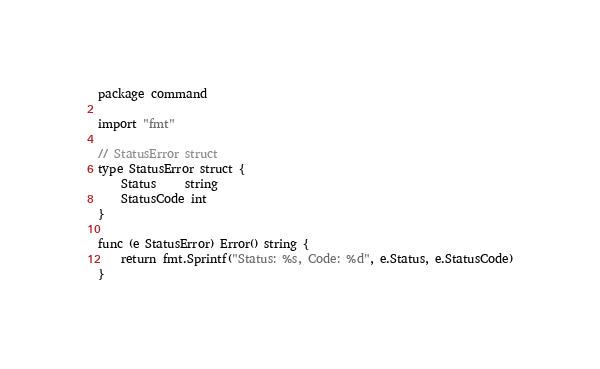Convert code to text. <code><loc_0><loc_0><loc_500><loc_500><_Go_>package command

import "fmt"

// StatusError struct
type StatusError struct {
	Status     string
	StatusCode int
}

func (e StatusError) Error() string {
	return fmt.Sprintf("Status: %s, Code: %d", e.Status, e.StatusCode)
}
</code> 